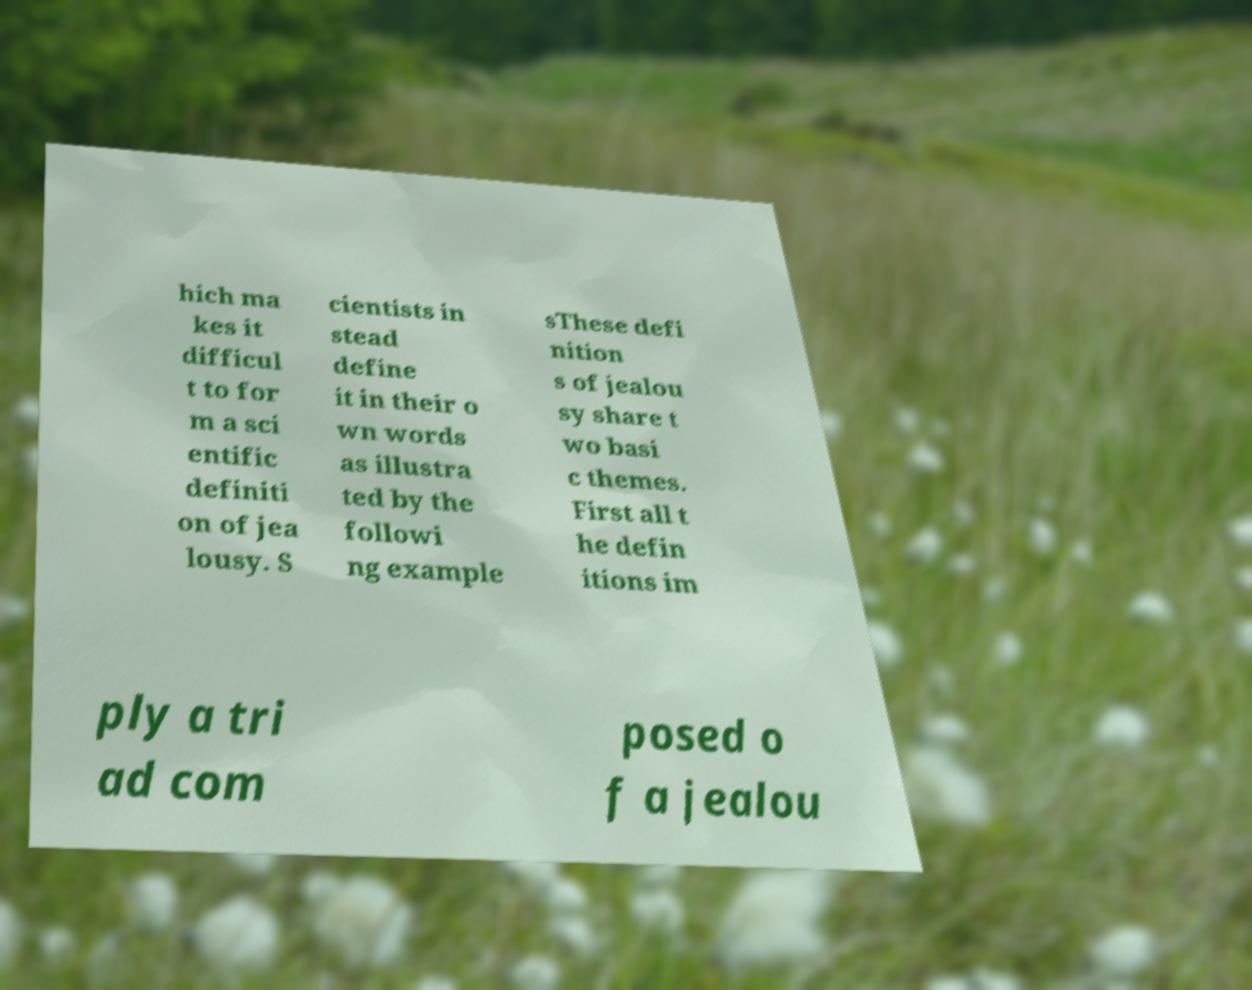For documentation purposes, I need the text within this image transcribed. Could you provide that? hich ma kes it difficul t to for m a sci entific definiti on of jea lousy. S cientists in stead define it in their o wn words as illustra ted by the followi ng example sThese defi nition s of jealou sy share t wo basi c themes. First all t he defin itions im ply a tri ad com posed o f a jealou 